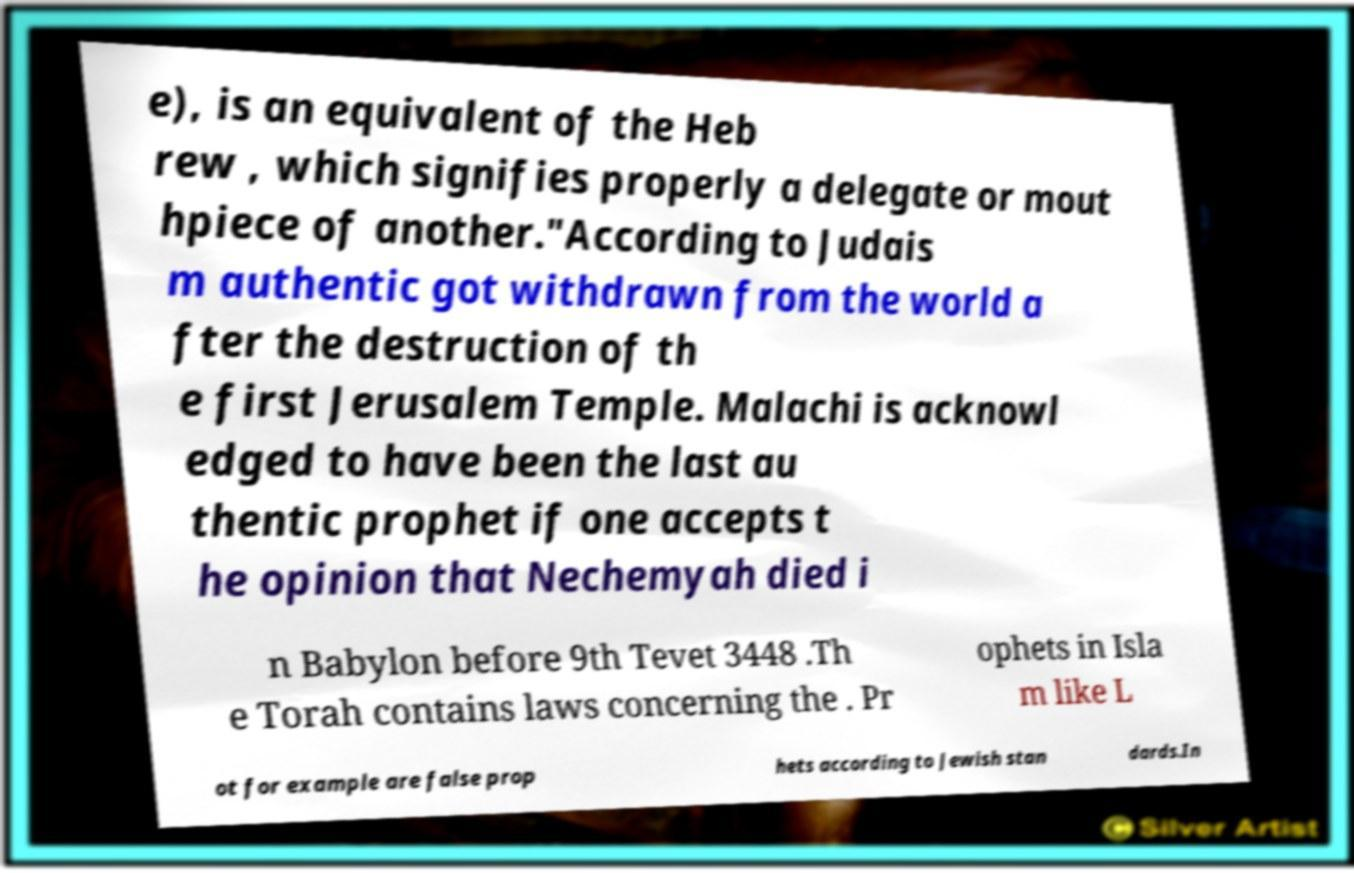What messages or text are displayed in this image? I need them in a readable, typed format. e), is an equivalent of the Heb rew , which signifies properly a delegate or mout hpiece of another."According to Judais m authentic got withdrawn from the world a fter the destruction of th e first Jerusalem Temple. Malachi is acknowl edged to have been the last au thentic prophet if one accepts t he opinion that Nechemyah died i n Babylon before 9th Tevet 3448 .Th e Torah contains laws concerning the . Pr ophets in Isla m like L ot for example are false prop hets according to Jewish stan dards.In 